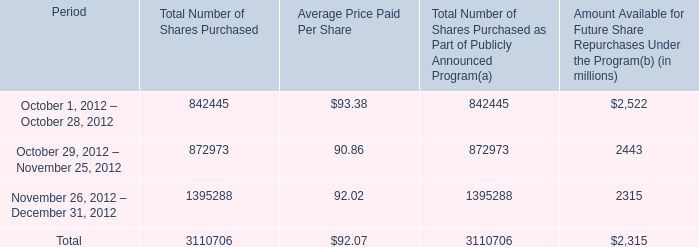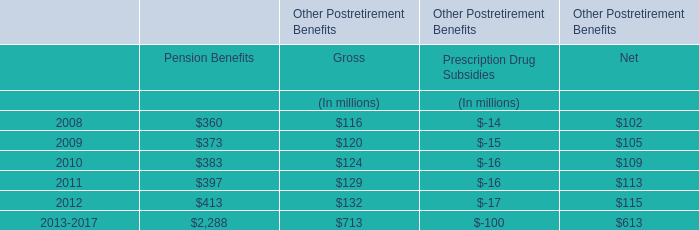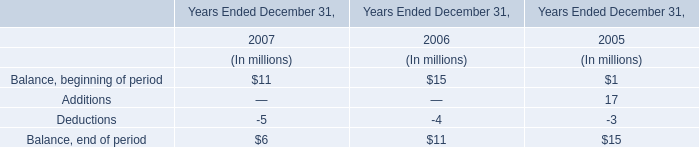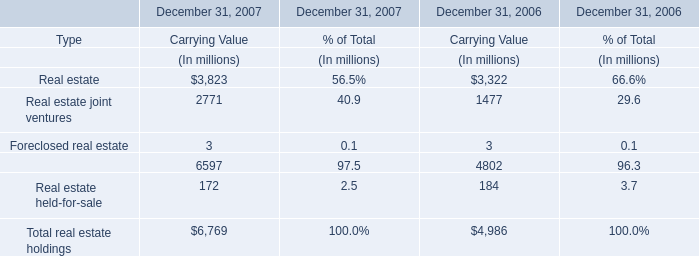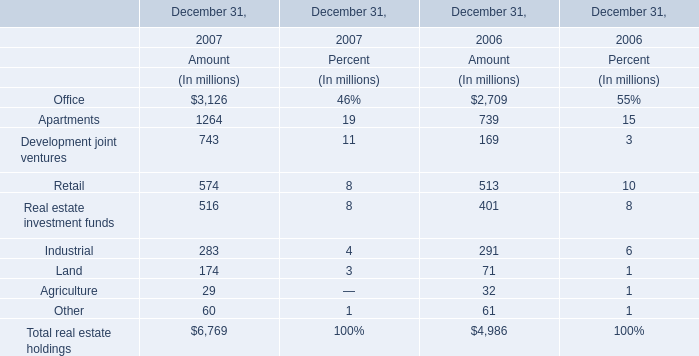What was the total amount of Amount in the range of 0 and 100 in 2007? (in million) 
Computations: (29 + 60)
Answer: 89.0. 